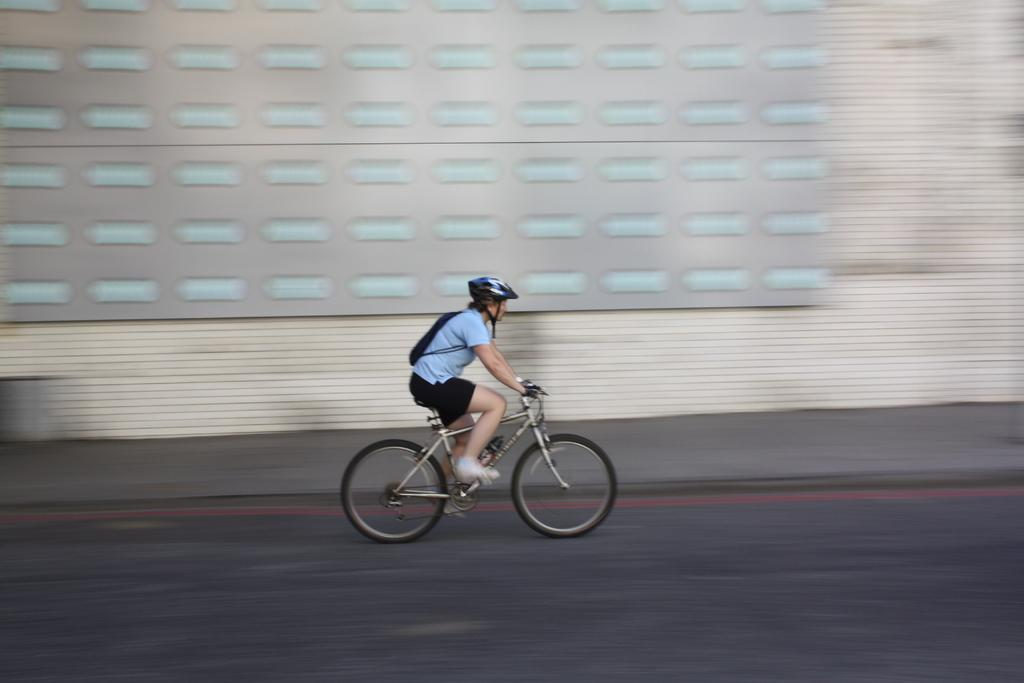What is the person in the image doing? The person is riding a bicycle in the image. What is the person wearing while riding the bicycle? The person is wearing a helmet. What else is the person carrying while riding the bicycle? The person is carrying a bag. Where is the bicycle located in the image? The bicycle is on the road. What can be seen in the background of the image? There is a wall and a footpath in the background of the image. What type of relation does the person have with the quince in the image? There is no quince present in the image, so the person cannot have any relation with it. 